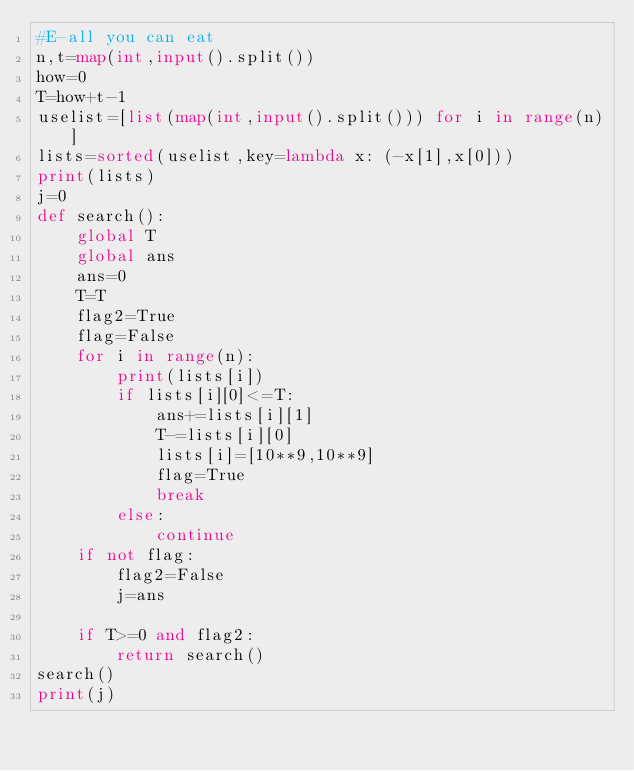Convert code to text. <code><loc_0><loc_0><loc_500><loc_500><_Python_>#E-all you can eat
n,t=map(int,input().split())
how=0
T=how+t-1
uselist=[list(map(int,input().split())) for i in range(n)]
lists=sorted(uselist,key=lambda x: (-x[1],x[0]))
print(lists)
j=0
def search():
    global T
    global ans
    ans=0
    T=T
    flag2=True
    flag=False
    for i in range(n):
        print(lists[i])
        if lists[i][0]<=T:
            ans+=lists[i][1]
            T-=lists[i][0]
            lists[i]=[10**9,10**9]
            flag=True
            break
        else:
            continue
    if not flag:
        flag2=False
        j=ans

    if T>=0 and flag2:
        return search()
search()
print(j)</code> 